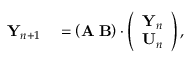Convert formula to latex. <formula><loc_0><loc_0><loc_500><loc_500>\begin{array} { r l } { { Y } _ { n + 1 } } & = \left ( { A } \, { B } \right ) \cdot \left ( \begin{array} { l } { { Y } _ { n } } \\ { { U } _ { n } } \end{array} \right ) , } \end{array}</formula> 